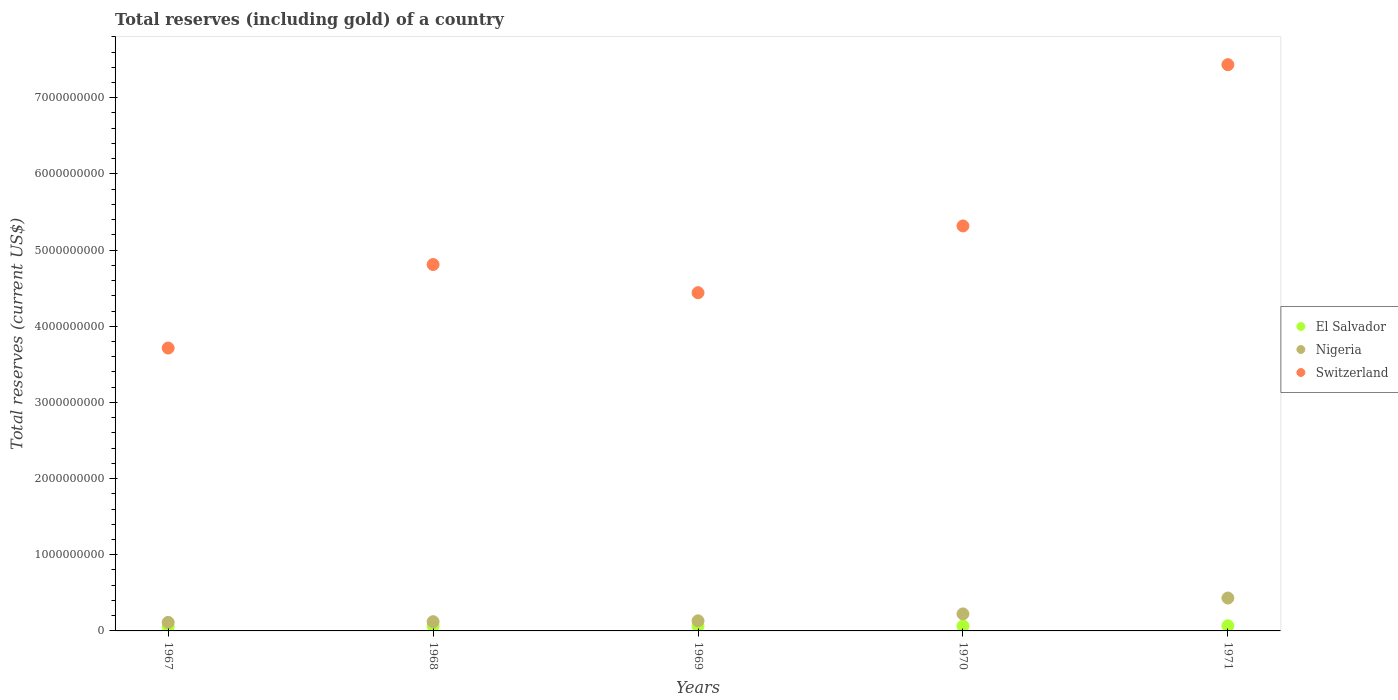How many different coloured dotlines are there?
Offer a terse response. 3. Is the number of dotlines equal to the number of legend labels?
Offer a very short reply. Yes. What is the total reserves (including gold) in El Salvador in 1970?
Your answer should be very brief. 6.39e+07. Across all years, what is the maximum total reserves (including gold) in Switzerland?
Offer a very short reply. 7.43e+09. Across all years, what is the minimum total reserves (including gold) in Switzerland?
Give a very brief answer. 3.71e+09. In which year was the total reserves (including gold) in El Salvador maximum?
Make the answer very short. 1971. In which year was the total reserves (including gold) in El Salvador minimum?
Your answer should be very brief. 1967. What is the total total reserves (including gold) in Switzerland in the graph?
Your answer should be compact. 2.57e+1. What is the difference between the total reserves (including gold) in Switzerland in 1967 and that in 1971?
Offer a very short reply. -3.72e+09. What is the difference between the total reserves (including gold) in Nigeria in 1969 and the total reserves (including gold) in El Salvador in 1970?
Your answer should be very brief. 6.86e+07. What is the average total reserves (including gold) in Nigeria per year?
Give a very brief answer. 2.04e+08. In the year 1971, what is the difference between the total reserves (including gold) in El Salvador and total reserves (including gold) in Nigeria?
Make the answer very short. -3.64e+08. In how many years, is the total reserves (including gold) in Nigeria greater than 800000000 US$?
Offer a terse response. 0. What is the ratio of the total reserves (including gold) in Switzerland in 1967 to that in 1970?
Offer a terse response. 0.7. Is the total reserves (including gold) in Switzerland in 1970 less than that in 1971?
Your answer should be compact. Yes. Is the difference between the total reserves (including gold) in El Salvador in 1968 and 1969 greater than the difference between the total reserves (including gold) in Nigeria in 1968 and 1969?
Your answer should be very brief. Yes. What is the difference between the highest and the second highest total reserves (including gold) in El Salvador?
Make the answer very short. 2.20e+06. What is the difference between the highest and the lowest total reserves (including gold) in Switzerland?
Provide a short and direct response. 3.72e+09. In how many years, is the total reserves (including gold) in Nigeria greater than the average total reserves (including gold) in Nigeria taken over all years?
Make the answer very short. 2. Does the total reserves (including gold) in Nigeria monotonically increase over the years?
Your answer should be very brief. Yes. Is the total reserves (including gold) in Switzerland strictly greater than the total reserves (including gold) in Nigeria over the years?
Your answer should be compact. Yes. Is the total reserves (including gold) in Switzerland strictly less than the total reserves (including gold) in El Salvador over the years?
Provide a short and direct response. No. How many dotlines are there?
Your answer should be very brief. 3. Are the values on the major ticks of Y-axis written in scientific E-notation?
Offer a terse response. No. What is the title of the graph?
Make the answer very short. Total reserves (including gold) of a country. Does "Dominican Republic" appear as one of the legend labels in the graph?
Make the answer very short. No. What is the label or title of the X-axis?
Ensure brevity in your answer.  Years. What is the label or title of the Y-axis?
Keep it short and to the point. Total reserves (current US$). What is the Total reserves (current US$) of El Salvador in 1967?
Provide a short and direct response. 5.49e+07. What is the Total reserves (current US$) in Nigeria in 1967?
Provide a short and direct response. 1.12e+08. What is the Total reserves (current US$) of Switzerland in 1967?
Give a very brief answer. 3.71e+09. What is the Total reserves (current US$) in El Salvador in 1968?
Your response must be concise. 6.54e+07. What is the Total reserves (current US$) in Nigeria in 1968?
Your response must be concise. 1.21e+08. What is the Total reserves (current US$) of Switzerland in 1968?
Your answer should be compact. 4.81e+09. What is the Total reserves (current US$) of El Salvador in 1969?
Offer a very short reply. 6.39e+07. What is the Total reserves (current US$) of Nigeria in 1969?
Provide a succinct answer. 1.32e+08. What is the Total reserves (current US$) in Switzerland in 1969?
Your response must be concise. 4.44e+09. What is the Total reserves (current US$) in El Salvador in 1970?
Offer a terse response. 6.39e+07. What is the Total reserves (current US$) of Nigeria in 1970?
Your response must be concise. 2.23e+08. What is the Total reserves (current US$) of Switzerland in 1970?
Offer a terse response. 5.32e+09. What is the Total reserves (current US$) of El Salvador in 1971?
Make the answer very short. 6.76e+07. What is the Total reserves (current US$) in Nigeria in 1971?
Give a very brief answer. 4.32e+08. What is the Total reserves (current US$) of Switzerland in 1971?
Make the answer very short. 7.43e+09. Across all years, what is the maximum Total reserves (current US$) of El Salvador?
Ensure brevity in your answer.  6.76e+07. Across all years, what is the maximum Total reserves (current US$) of Nigeria?
Your answer should be compact. 4.32e+08. Across all years, what is the maximum Total reserves (current US$) of Switzerland?
Ensure brevity in your answer.  7.43e+09. Across all years, what is the minimum Total reserves (current US$) of El Salvador?
Your response must be concise. 5.49e+07. Across all years, what is the minimum Total reserves (current US$) in Nigeria?
Give a very brief answer. 1.12e+08. Across all years, what is the minimum Total reserves (current US$) in Switzerland?
Give a very brief answer. 3.71e+09. What is the total Total reserves (current US$) in El Salvador in the graph?
Your response must be concise. 3.16e+08. What is the total Total reserves (current US$) in Nigeria in the graph?
Your answer should be compact. 1.02e+09. What is the total Total reserves (current US$) in Switzerland in the graph?
Offer a terse response. 2.57e+1. What is the difference between the Total reserves (current US$) in El Salvador in 1967 and that in 1968?
Ensure brevity in your answer.  -1.06e+07. What is the difference between the Total reserves (current US$) in Nigeria in 1967 and that in 1968?
Offer a very short reply. -8.84e+06. What is the difference between the Total reserves (current US$) of Switzerland in 1967 and that in 1968?
Provide a short and direct response. -1.10e+09. What is the difference between the Total reserves (current US$) in El Salvador in 1967 and that in 1969?
Give a very brief answer. -9.00e+06. What is the difference between the Total reserves (current US$) in Nigeria in 1967 and that in 1969?
Give a very brief answer. -2.01e+07. What is the difference between the Total reserves (current US$) in Switzerland in 1967 and that in 1969?
Offer a terse response. -7.26e+08. What is the difference between the Total reserves (current US$) in El Salvador in 1967 and that in 1970?
Ensure brevity in your answer.  -9.00e+06. What is the difference between the Total reserves (current US$) in Nigeria in 1967 and that in 1970?
Give a very brief answer. -1.11e+08. What is the difference between the Total reserves (current US$) in Switzerland in 1967 and that in 1970?
Your response must be concise. -1.60e+09. What is the difference between the Total reserves (current US$) in El Salvador in 1967 and that in 1971?
Keep it short and to the point. -1.28e+07. What is the difference between the Total reserves (current US$) in Nigeria in 1967 and that in 1971?
Your answer should be compact. -3.20e+08. What is the difference between the Total reserves (current US$) of Switzerland in 1967 and that in 1971?
Give a very brief answer. -3.72e+09. What is the difference between the Total reserves (current US$) in El Salvador in 1968 and that in 1969?
Offer a very short reply. 1.57e+06. What is the difference between the Total reserves (current US$) in Nigeria in 1968 and that in 1969?
Make the answer very short. -1.13e+07. What is the difference between the Total reserves (current US$) of Switzerland in 1968 and that in 1969?
Offer a very short reply. 3.70e+08. What is the difference between the Total reserves (current US$) in El Salvador in 1968 and that in 1970?
Your answer should be compact. 1.57e+06. What is the difference between the Total reserves (current US$) in Nigeria in 1968 and that in 1970?
Provide a succinct answer. -1.02e+08. What is the difference between the Total reserves (current US$) in Switzerland in 1968 and that in 1970?
Provide a short and direct response. -5.07e+08. What is the difference between the Total reserves (current US$) in El Salvador in 1968 and that in 1971?
Provide a short and direct response. -2.20e+06. What is the difference between the Total reserves (current US$) of Nigeria in 1968 and that in 1971?
Provide a short and direct response. -3.11e+08. What is the difference between the Total reserves (current US$) of Switzerland in 1968 and that in 1971?
Your response must be concise. -2.62e+09. What is the difference between the Total reserves (current US$) in El Salvador in 1969 and that in 1970?
Keep it short and to the point. 203. What is the difference between the Total reserves (current US$) in Nigeria in 1969 and that in 1970?
Your answer should be compact. -9.10e+07. What is the difference between the Total reserves (current US$) of Switzerland in 1969 and that in 1970?
Give a very brief answer. -8.77e+08. What is the difference between the Total reserves (current US$) in El Salvador in 1969 and that in 1971?
Provide a short and direct response. -3.77e+06. What is the difference between the Total reserves (current US$) of Nigeria in 1969 and that in 1971?
Offer a terse response. -2.99e+08. What is the difference between the Total reserves (current US$) in Switzerland in 1969 and that in 1971?
Provide a succinct answer. -2.99e+09. What is the difference between the Total reserves (current US$) in El Salvador in 1970 and that in 1971?
Your answer should be very brief. -3.77e+06. What is the difference between the Total reserves (current US$) of Nigeria in 1970 and that in 1971?
Provide a short and direct response. -2.08e+08. What is the difference between the Total reserves (current US$) of Switzerland in 1970 and that in 1971?
Keep it short and to the point. -2.12e+09. What is the difference between the Total reserves (current US$) of El Salvador in 1967 and the Total reserves (current US$) of Nigeria in 1968?
Offer a terse response. -6.63e+07. What is the difference between the Total reserves (current US$) of El Salvador in 1967 and the Total reserves (current US$) of Switzerland in 1968?
Offer a very short reply. -4.76e+09. What is the difference between the Total reserves (current US$) of Nigeria in 1967 and the Total reserves (current US$) of Switzerland in 1968?
Offer a very short reply. -4.70e+09. What is the difference between the Total reserves (current US$) in El Salvador in 1967 and the Total reserves (current US$) in Nigeria in 1969?
Ensure brevity in your answer.  -7.76e+07. What is the difference between the Total reserves (current US$) in El Salvador in 1967 and the Total reserves (current US$) in Switzerland in 1969?
Provide a succinct answer. -4.39e+09. What is the difference between the Total reserves (current US$) of Nigeria in 1967 and the Total reserves (current US$) of Switzerland in 1969?
Your response must be concise. -4.33e+09. What is the difference between the Total reserves (current US$) in El Salvador in 1967 and the Total reserves (current US$) in Nigeria in 1970?
Give a very brief answer. -1.69e+08. What is the difference between the Total reserves (current US$) of El Salvador in 1967 and the Total reserves (current US$) of Switzerland in 1970?
Your answer should be compact. -5.26e+09. What is the difference between the Total reserves (current US$) in Nigeria in 1967 and the Total reserves (current US$) in Switzerland in 1970?
Give a very brief answer. -5.20e+09. What is the difference between the Total reserves (current US$) in El Salvador in 1967 and the Total reserves (current US$) in Nigeria in 1971?
Give a very brief answer. -3.77e+08. What is the difference between the Total reserves (current US$) in El Salvador in 1967 and the Total reserves (current US$) in Switzerland in 1971?
Your answer should be very brief. -7.38e+09. What is the difference between the Total reserves (current US$) of Nigeria in 1967 and the Total reserves (current US$) of Switzerland in 1971?
Ensure brevity in your answer.  -7.32e+09. What is the difference between the Total reserves (current US$) in El Salvador in 1968 and the Total reserves (current US$) in Nigeria in 1969?
Keep it short and to the point. -6.70e+07. What is the difference between the Total reserves (current US$) in El Salvador in 1968 and the Total reserves (current US$) in Switzerland in 1969?
Your answer should be very brief. -4.37e+09. What is the difference between the Total reserves (current US$) in Nigeria in 1968 and the Total reserves (current US$) in Switzerland in 1969?
Ensure brevity in your answer.  -4.32e+09. What is the difference between the Total reserves (current US$) of El Salvador in 1968 and the Total reserves (current US$) of Nigeria in 1970?
Provide a succinct answer. -1.58e+08. What is the difference between the Total reserves (current US$) of El Salvador in 1968 and the Total reserves (current US$) of Switzerland in 1970?
Offer a very short reply. -5.25e+09. What is the difference between the Total reserves (current US$) of Nigeria in 1968 and the Total reserves (current US$) of Switzerland in 1970?
Offer a very short reply. -5.20e+09. What is the difference between the Total reserves (current US$) of El Salvador in 1968 and the Total reserves (current US$) of Nigeria in 1971?
Provide a short and direct response. -3.66e+08. What is the difference between the Total reserves (current US$) in El Salvador in 1968 and the Total reserves (current US$) in Switzerland in 1971?
Offer a very short reply. -7.37e+09. What is the difference between the Total reserves (current US$) of Nigeria in 1968 and the Total reserves (current US$) of Switzerland in 1971?
Ensure brevity in your answer.  -7.31e+09. What is the difference between the Total reserves (current US$) in El Salvador in 1969 and the Total reserves (current US$) in Nigeria in 1970?
Provide a short and direct response. -1.60e+08. What is the difference between the Total reserves (current US$) of El Salvador in 1969 and the Total reserves (current US$) of Switzerland in 1970?
Your answer should be compact. -5.25e+09. What is the difference between the Total reserves (current US$) of Nigeria in 1969 and the Total reserves (current US$) of Switzerland in 1970?
Your answer should be very brief. -5.18e+09. What is the difference between the Total reserves (current US$) of El Salvador in 1969 and the Total reserves (current US$) of Nigeria in 1971?
Give a very brief answer. -3.68e+08. What is the difference between the Total reserves (current US$) of El Salvador in 1969 and the Total reserves (current US$) of Switzerland in 1971?
Offer a very short reply. -7.37e+09. What is the difference between the Total reserves (current US$) of Nigeria in 1969 and the Total reserves (current US$) of Switzerland in 1971?
Offer a very short reply. -7.30e+09. What is the difference between the Total reserves (current US$) of El Salvador in 1970 and the Total reserves (current US$) of Nigeria in 1971?
Offer a very short reply. -3.68e+08. What is the difference between the Total reserves (current US$) of El Salvador in 1970 and the Total reserves (current US$) of Switzerland in 1971?
Your response must be concise. -7.37e+09. What is the difference between the Total reserves (current US$) in Nigeria in 1970 and the Total reserves (current US$) in Switzerland in 1971?
Ensure brevity in your answer.  -7.21e+09. What is the average Total reserves (current US$) in El Salvador per year?
Provide a short and direct response. 6.31e+07. What is the average Total reserves (current US$) in Nigeria per year?
Offer a very short reply. 2.04e+08. What is the average Total reserves (current US$) in Switzerland per year?
Provide a short and direct response. 5.14e+09. In the year 1967, what is the difference between the Total reserves (current US$) in El Salvador and Total reserves (current US$) in Nigeria?
Keep it short and to the point. -5.75e+07. In the year 1967, what is the difference between the Total reserves (current US$) of El Salvador and Total reserves (current US$) of Switzerland?
Your response must be concise. -3.66e+09. In the year 1967, what is the difference between the Total reserves (current US$) in Nigeria and Total reserves (current US$) in Switzerland?
Provide a succinct answer. -3.60e+09. In the year 1968, what is the difference between the Total reserves (current US$) in El Salvador and Total reserves (current US$) in Nigeria?
Make the answer very short. -5.57e+07. In the year 1968, what is the difference between the Total reserves (current US$) of El Salvador and Total reserves (current US$) of Switzerland?
Offer a terse response. -4.74e+09. In the year 1968, what is the difference between the Total reserves (current US$) in Nigeria and Total reserves (current US$) in Switzerland?
Offer a terse response. -4.69e+09. In the year 1969, what is the difference between the Total reserves (current US$) in El Salvador and Total reserves (current US$) in Nigeria?
Your answer should be very brief. -6.86e+07. In the year 1969, what is the difference between the Total reserves (current US$) of El Salvador and Total reserves (current US$) of Switzerland?
Make the answer very short. -4.38e+09. In the year 1969, what is the difference between the Total reserves (current US$) in Nigeria and Total reserves (current US$) in Switzerland?
Give a very brief answer. -4.31e+09. In the year 1970, what is the difference between the Total reserves (current US$) in El Salvador and Total reserves (current US$) in Nigeria?
Give a very brief answer. -1.60e+08. In the year 1970, what is the difference between the Total reserves (current US$) of El Salvador and Total reserves (current US$) of Switzerland?
Provide a short and direct response. -5.25e+09. In the year 1970, what is the difference between the Total reserves (current US$) in Nigeria and Total reserves (current US$) in Switzerland?
Provide a succinct answer. -5.09e+09. In the year 1971, what is the difference between the Total reserves (current US$) in El Salvador and Total reserves (current US$) in Nigeria?
Keep it short and to the point. -3.64e+08. In the year 1971, what is the difference between the Total reserves (current US$) in El Salvador and Total reserves (current US$) in Switzerland?
Your answer should be compact. -7.37e+09. In the year 1971, what is the difference between the Total reserves (current US$) of Nigeria and Total reserves (current US$) of Switzerland?
Give a very brief answer. -7.00e+09. What is the ratio of the Total reserves (current US$) of El Salvador in 1967 to that in 1968?
Offer a terse response. 0.84. What is the ratio of the Total reserves (current US$) in Nigeria in 1967 to that in 1968?
Your answer should be compact. 0.93. What is the ratio of the Total reserves (current US$) in Switzerland in 1967 to that in 1968?
Provide a short and direct response. 0.77. What is the ratio of the Total reserves (current US$) in El Salvador in 1967 to that in 1969?
Offer a terse response. 0.86. What is the ratio of the Total reserves (current US$) in Nigeria in 1967 to that in 1969?
Your answer should be very brief. 0.85. What is the ratio of the Total reserves (current US$) of Switzerland in 1967 to that in 1969?
Provide a succinct answer. 0.84. What is the ratio of the Total reserves (current US$) of El Salvador in 1967 to that in 1970?
Make the answer very short. 0.86. What is the ratio of the Total reserves (current US$) in Nigeria in 1967 to that in 1970?
Your answer should be very brief. 0.5. What is the ratio of the Total reserves (current US$) of Switzerland in 1967 to that in 1970?
Make the answer very short. 0.7. What is the ratio of the Total reserves (current US$) of El Salvador in 1967 to that in 1971?
Your answer should be compact. 0.81. What is the ratio of the Total reserves (current US$) of Nigeria in 1967 to that in 1971?
Your response must be concise. 0.26. What is the ratio of the Total reserves (current US$) of Switzerland in 1967 to that in 1971?
Offer a very short reply. 0.5. What is the ratio of the Total reserves (current US$) of El Salvador in 1968 to that in 1969?
Offer a very short reply. 1.02. What is the ratio of the Total reserves (current US$) in Nigeria in 1968 to that in 1969?
Ensure brevity in your answer.  0.92. What is the ratio of the Total reserves (current US$) in El Salvador in 1968 to that in 1970?
Keep it short and to the point. 1.02. What is the ratio of the Total reserves (current US$) of Nigeria in 1968 to that in 1970?
Offer a terse response. 0.54. What is the ratio of the Total reserves (current US$) of Switzerland in 1968 to that in 1970?
Your answer should be very brief. 0.9. What is the ratio of the Total reserves (current US$) of El Salvador in 1968 to that in 1971?
Keep it short and to the point. 0.97. What is the ratio of the Total reserves (current US$) of Nigeria in 1968 to that in 1971?
Keep it short and to the point. 0.28. What is the ratio of the Total reserves (current US$) in Switzerland in 1968 to that in 1971?
Provide a short and direct response. 0.65. What is the ratio of the Total reserves (current US$) of El Salvador in 1969 to that in 1970?
Offer a very short reply. 1. What is the ratio of the Total reserves (current US$) of Nigeria in 1969 to that in 1970?
Your response must be concise. 0.59. What is the ratio of the Total reserves (current US$) in Switzerland in 1969 to that in 1970?
Offer a terse response. 0.84. What is the ratio of the Total reserves (current US$) in El Salvador in 1969 to that in 1971?
Ensure brevity in your answer.  0.94. What is the ratio of the Total reserves (current US$) in Nigeria in 1969 to that in 1971?
Your answer should be very brief. 0.31. What is the ratio of the Total reserves (current US$) in Switzerland in 1969 to that in 1971?
Your answer should be very brief. 0.6. What is the ratio of the Total reserves (current US$) of El Salvador in 1970 to that in 1971?
Your response must be concise. 0.94. What is the ratio of the Total reserves (current US$) in Nigeria in 1970 to that in 1971?
Provide a succinct answer. 0.52. What is the ratio of the Total reserves (current US$) of Switzerland in 1970 to that in 1971?
Ensure brevity in your answer.  0.72. What is the difference between the highest and the second highest Total reserves (current US$) in El Salvador?
Your response must be concise. 2.20e+06. What is the difference between the highest and the second highest Total reserves (current US$) of Nigeria?
Provide a short and direct response. 2.08e+08. What is the difference between the highest and the second highest Total reserves (current US$) of Switzerland?
Your answer should be compact. 2.12e+09. What is the difference between the highest and the lowest Total reserves (current US$) of El Salvador?
Ensure brevity in your answer.  1.28e+07. What is the difference between the highest and the lowest Total reserves (current US$) of Nigeria?
Your answer should be very brief. 3.20e+08. What is the difference between the highest and the lowest Total reserves (current US$) in Switzerland?
Your answer should be very brief. 3.72e+09. 